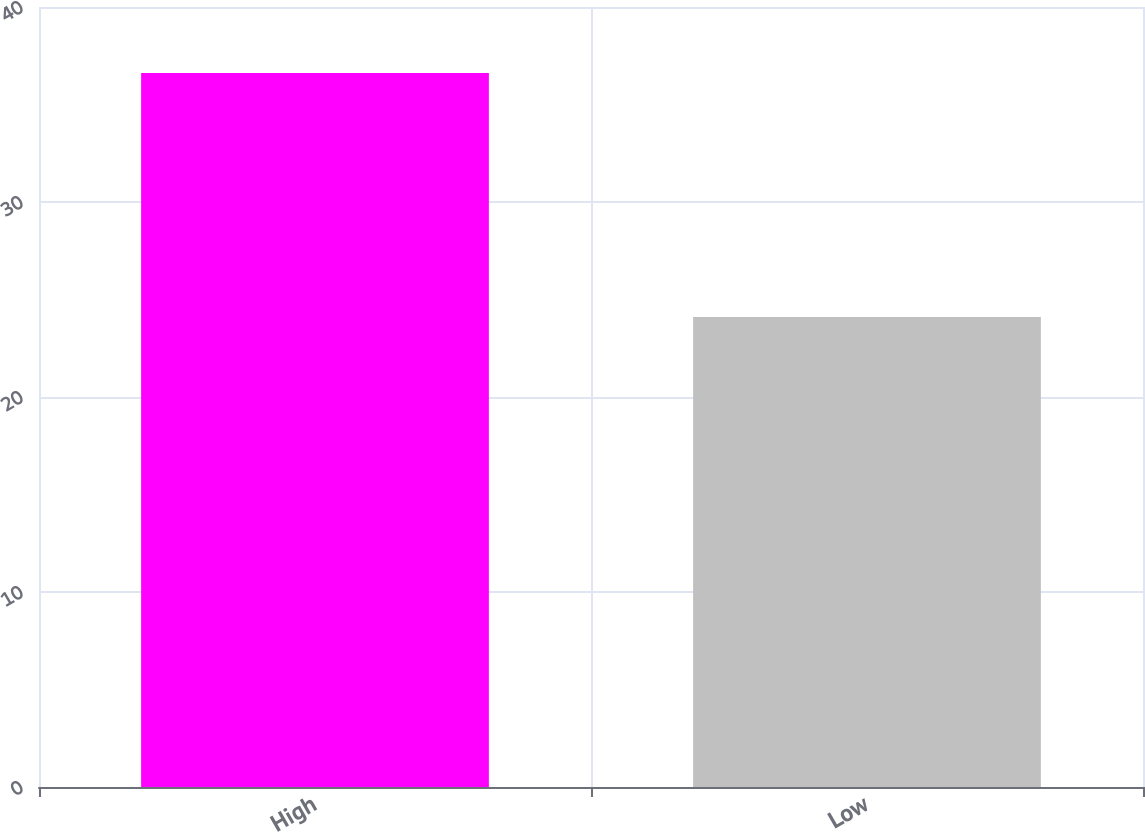<chart> <loc_0><loc_0><loc_500><loc_500><bar_chart><fcel>High<fcel>Low<nl><fcel>36.61<fcel>24.1<nl></chart> 